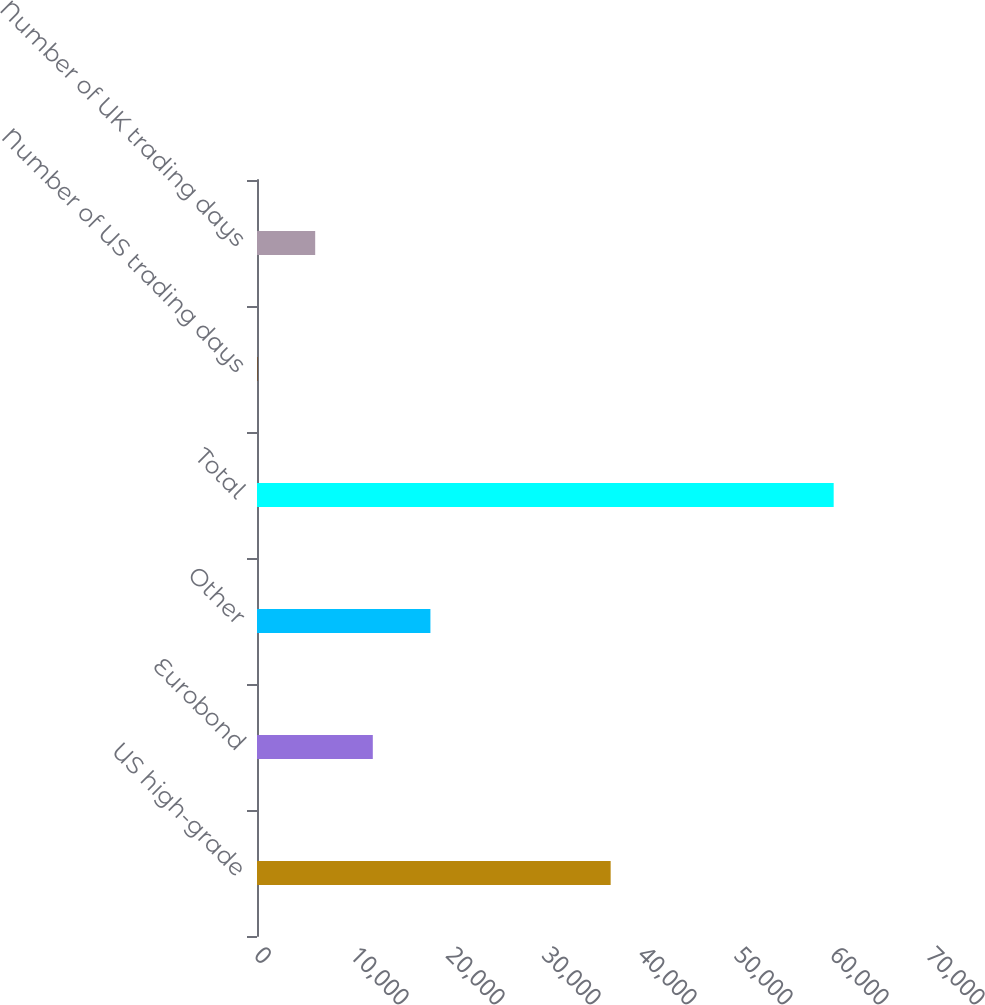Convert chart. <chart><loc_0><loc_0><loc_500><loc_500><bar_chart><fcel>US high-grade<fcel>Eurobond<fcel>Other<fcel>Total<fcel>Number of US trading days<fcel>Number of UK trading days<nl><fcel>36839<fcel>12063<fcel>18064<fcel>60071<fcel>61<fcel>6062<nl></chart> 